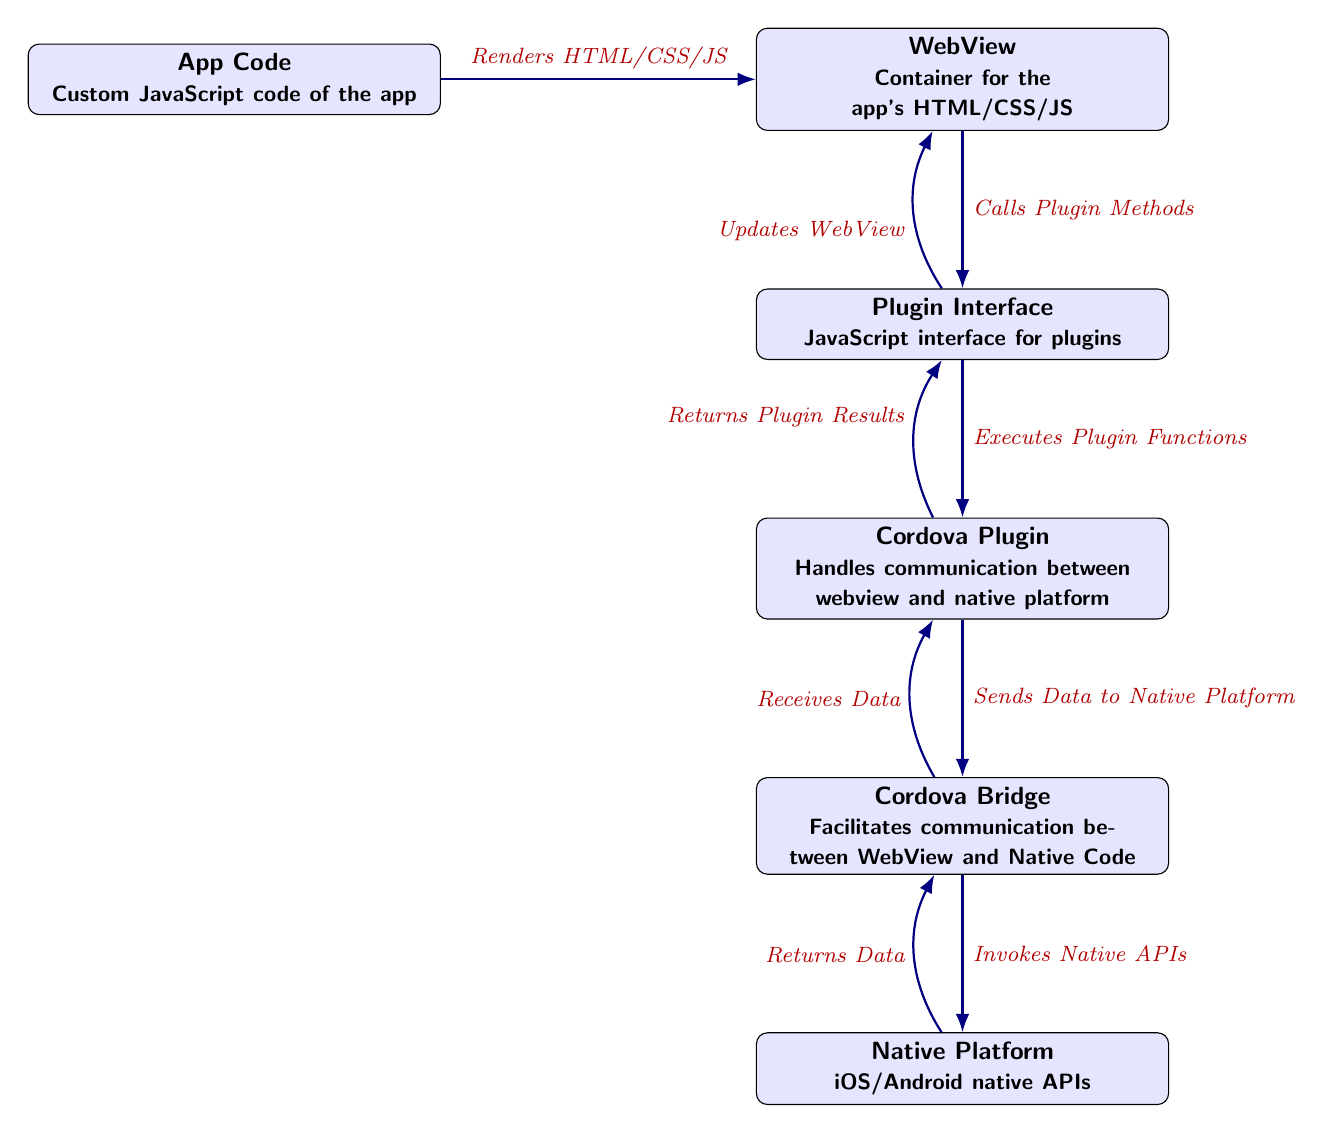What is the topmost node in the diagram? The topmost node in the diagram is the WebView, which serves as the container for the app's HTML/CSS/JavaScript.
Answer: WebView How many nodes are present in the diagram? By counting each distinct box from the topmost node (WebView) to the bottommost node (Native Platform), there are five nodes in total.
Answer: 5 Which node receives data from the Native Platform? The node that receives data back from the Native Platform is the Cordova Bridge, indicated by the returning arrow labeled "Returns Data."
Answer: Cordova Bridge What relationship exists between the Plugin Interface and the Cordova Plugin? The relationship is that the Plugin Interface executes plugin functions as indicated by the arrow between the two nodes.
Answer: Executes Plugin Functions What action is performed by the App Code? The App Code renders HTML/CSS/JS, which is shown by the arrow pointing from App Code to the WebView labeled "Renders HTML/CSS/JS."
Answer: Renders HTML/CSS/JS Which two nodes are connected by the arrow labeled "Returns Plugin Results"? The arrow labeled "Returns Plugin Results" connects the Cordova Plugin node back to the Plugin Interface node.
Answer: Cordova Plugin and Plugin Interface What happens after the Cordova Plugin sends data to the Native Platform? After sending data to the Native Platform, the Cordova Bridge invokes native APIs, as shown by the directed arrow from Cordova Plugin to Cordova Bridge.
Answer: Invokes Native APIs How does the system update the WebView after processing? The system updates the WebView through the Plugin Interface that sends updates back to the WebView as indicated by the arrow labeled "Updates WebView."
Answer: Updates WebView Which node is closest to the Native Platform? The closest node to the Native Platform, positioned directly above it, is the Cordova Bridge, as depicted in the diagram layout.
Answer: Cordova Bridge 